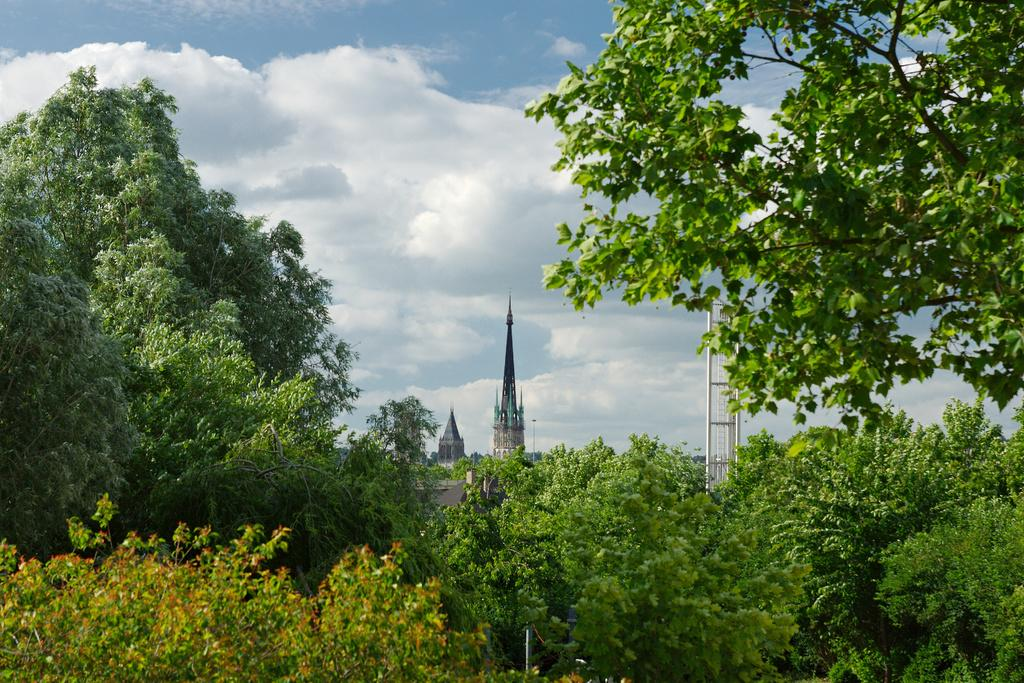What is located in the center of the image? There are buildings, trees, and a tower in the center of the image. Can you describe the tower in the image? The tower is located in the center of the image. What can be seen in the sky at the top of the image? Clouds are present in the sky at the top of the image. What type of tramp is visible in the image? There is no tramp present in the image. How does the structure of the buildings affect the acoustics in the image? There is no information about the acoustics in the image, and the structure of the buildings cannot be determined from the provided facts. 